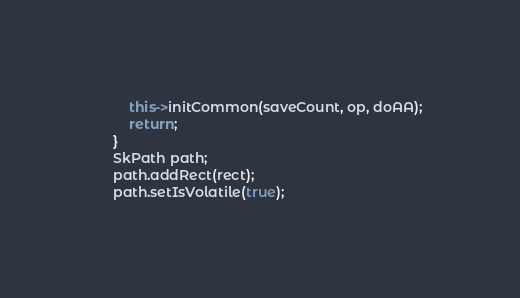Convert code to text. <code><loc_0><loc_0><loc_500><loc_500><_C++_>        this->initCommon(saveCount, op, doAA);
        return;
    }
    SkPath path;
    path.addRect(rect);
    path.setIsVolatile(true);</code> 